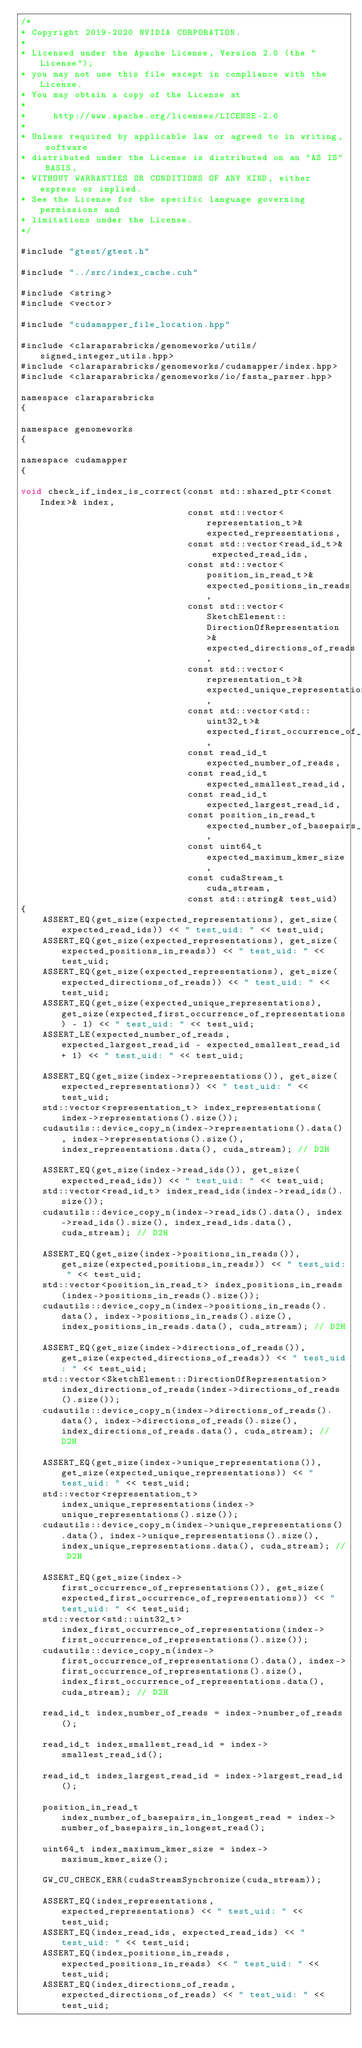<code> <loc_0><loc_0><loc_500><loc_500><_Cuda_>/*
* Copyright 2019-2020 NVIDIA CORPORATION.
*
* Licensed under the Apache License, Version 2.0 (the "License");
* you may not use this file except in compliance with the License.
* You may obtain a copy of the License at
*
*     http://www.apache.org/licenses/LICENSE-2.0
*
* Unless required by applicable law or agreed to in writing, software
* distributed under the License is distributed on an "AS IS" BASIS,
* WITHOUT WARRANTIES OR CONDITIONS OF ANY KIND, either express or implied.
* See the License for the specific language governing permissions and
* limitations under the License.
*/

#include "gtest/gtest.h"

#include "../src/index_cache.cuh"

#include <string>
#include <vector>

#include "cudamapper_file_location.hpp"

#include <claraparabricks/genomeworks/utils/signed_integer_utils.hpp>
#include <claraparabricks/genomeworks/cudamapper/index.hpp>
#include <claraparabricks/genomeworks/io/fasta_parser.hpp>

namespace claraparabricks
{

namespace genomeworks
{

namespace cudamapper
{

void check_if_index_is_correct(const std::shared_ptr<const Index>& index,
                               const std::vector<representation_t>& expected_representations,
                               const std::vector<read_id_t>& expected_read_ids,
                               const std::vector<position_in_read_t>& expected_positions_in_reads,
                               const std::vector<SketchElement::DirectionOfRepresentation>& expected_directions_of_reads,
                               const std::vector<representation_t>& expected_unique_representations,
                               const std::vector<std::uint32_t>& expected_first_occurrence_of_representations,
                               const read_id_t expected_number_of_reads,
                               const read_id_t expected_smallest_read_id,
                               const read_id_t expected_largest_read_id,
                               const position_in_read_t expected_number_of_basepairs_in_longest_read,
                               const uint64_t expected_maximum_kmer_size,
                               const cudaStream_t cuda_stream,
                               const std::string& test_uid)
{
    ASSERT_EQ(get_size(expected_representations), get_size(expected_read_ids)) << " test_uid: " << test_uid;
    ASSERT_EQ(get_size(expected_representations), get_size(expected_positions_in_reads)) << " test_uid: " << test_uid;
    ASSERT_EQ(get_size(expected_representations), get_size(expected_directions_of_reads)) << " test_uid: " << test_uid;
    ASSERT_EQ(get_size(expected_unique_representations), get_size(expected_first_occurrence_of_representations) - 1) << " test_uid: " << test_uid;
    ASSERT_LE(expected_number_of_reads, expected_largest_read_id - expected_smallest_read_id + 1) << " test_uid: " << test_uid;

    ASSERT_EQ(get_size(index->representations()), get_size(expected_representations)) << " test_uid: " << test_uid;
    std::vector<representation_t> index_representations(index->representations().size());
    cudautils::device_copy_n(index->representations().data(), index->representations().size(), index_representations.data(), cuda_stream); // D2H

    ASSERT_EQ(get_size(index->read_ids()), get_size(expected_read_ids)) << " test_uid: " << test_uid;
    std::vector<read_id_t> index_read_ids(index->read_ids().size());
    cudautils::device_copy_n(index->read_ids().data(), index->read_ids().size(), index_read_ids.data(), cuda_stream); // D2H

    ASSERT_EQ(get_size(index->positions_in_reads()), get_size(expected_positions_in_reads)) << " test_uid: " << test_uid;
    std::vector<position_in_read_t> index_positions_in_reads(index->positions_in_reads().size());
    cudautils::device_copy_n(index->positions_in_reads().data(), index->positions_in_reads().size(), index_positions_in_reads.data(), cuda_stream); // D2H

    ASSERT_EQ(get_size(index->directions_of_reads()), get_size(expected_directions_of_reads)) << " test_uid: " << test_uid;
    std::vector<SketchElement::DirectionOfRepresentation> index_directions_of_reads(index->directions_of_reads().size());
    cudautils::device_copy_n(index->directions_of_reads().data(), index->directions_of_reads().size(), index_directions_of_reads.data(), cuda_stream); // D2H

    ASSERT_EQ(get_size(index->unique_representations()), get_size(expected_unique_representations)) << " test_uid: " << test_uid;
    std::vector<representation_t> index_unique_representations(index->unique_representations().size());
    cudautils::device_copy_n(index->unique_representations().data(), index->unique_representations().size(), index_unique_representations.data(), cuda_stream); // D2H

    ASSERT_EQ(get_size(index->first_occurrence_of_representations()), get_size(expected_first_occurrence_of_representations)) << " test_uid: " << test_uid;
    std::vector<std::uint32_t> index_first_occurrence_of_representations(index->first_occurrence_of_representations().size());
    cudautils::device_copy_n(index->first_occurrence_of_representations().data(), index->first_occurrence_of_representations().size(), index_first_occurrence_of_representations.data(), cuda_stream); // D2H

    read_id_t index_number_of_reads = index->number_of_reads();

    read_id_t index_smallest_read_id = index->smallest_read_id();

    read_id_t index_largest_read_id = index->largest_read_id();

    position_in_read_t index_number_of_basepairs_in_longest_read = index->number_of_basepairs_in_longest_read();

    uint64_t index_maximum_kmer_size = index->maximum_kmer_size();

    GW_CU_CHECK_ERR(cudaStreamSynchronize(cuda_stream));

    ASSERT_EQ(index_representations, expected_representations) << " test_uid: " << test_uid;
    ASSERT_EQ(index_read_ids, expected_read_ids) << " test_uid: " << test_uid;
    ASSERT_EQ(index_positions_in_reads, expected_positions_in_reads) << " test_uid: " << test_uid;
    ASSERT_EQ(index_directions_of_reads, expected_directions_of_reads) << " test_uid: " << test_uid;</code> 